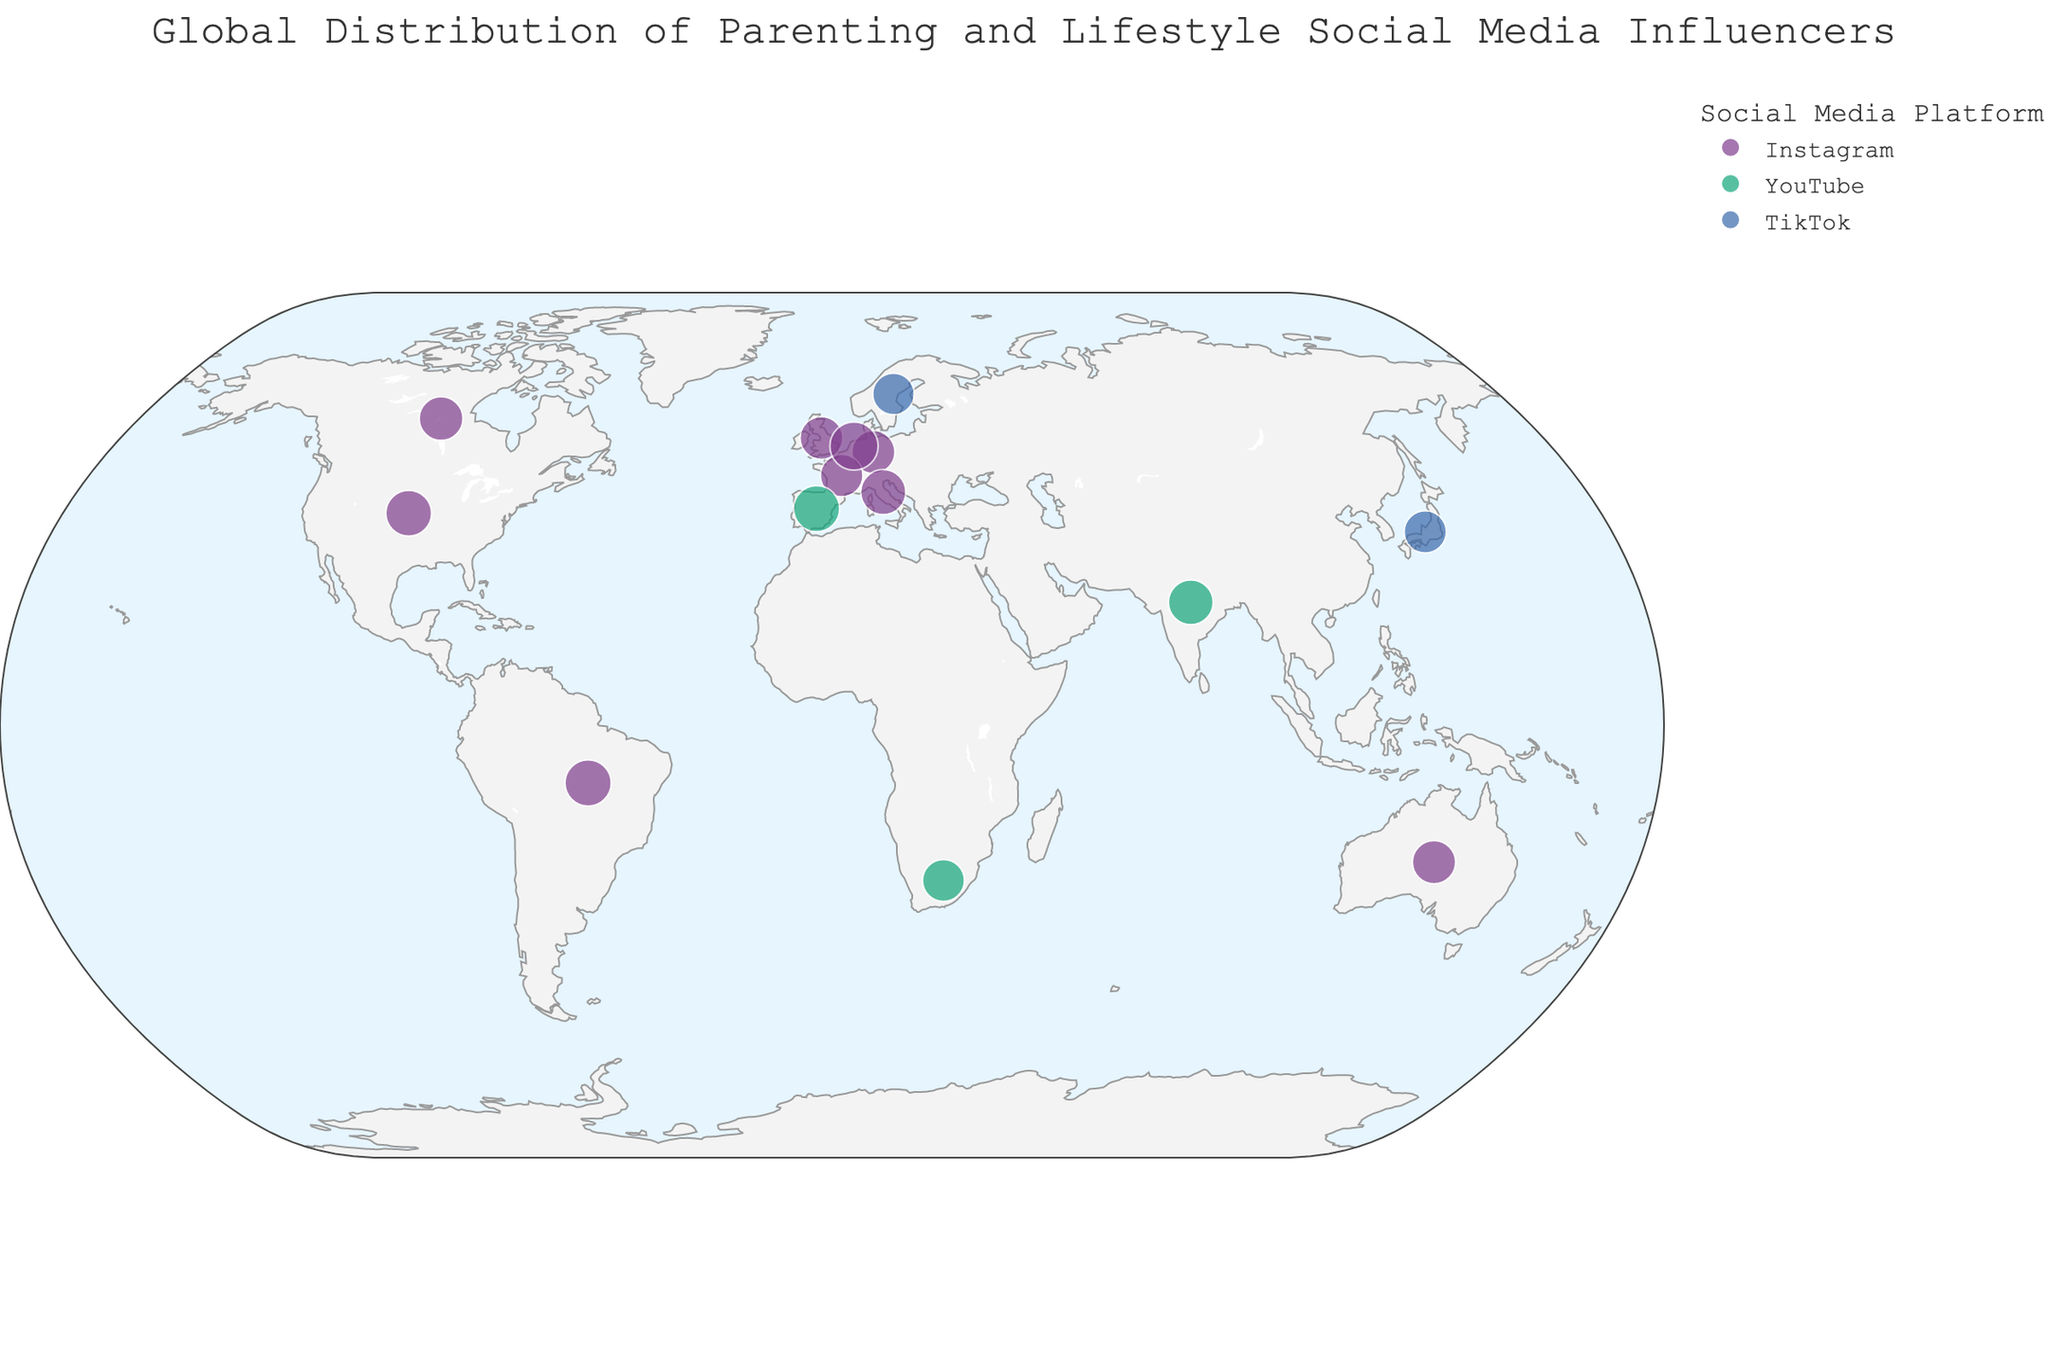What's the title of the figure? Look at the top of the plot where the title is centered.
Answer: "Global Distribution of Parenting and Lifestyle Social Media Influencers" Which social media platform has the most diversity in countries represented? Observe the variety of colors representing different platforms across the countries on the map.
Answer: Instagram Which influencer from Spain has a large following? Check the location marked in Spain and hover over it to see the influencer's details.
Answer: Verdeliss Which country has the influencer with the highest number of followers? Survey the scatter points and identify the largest one. Then, check the corresponding country.
Answer: Netherlands Which platform has influencers with the largest followings in general? Notice the size of the scatter points and identify the platform frequently associated with the largest points.
Answer: Instagram How many influencers are represented from the United States? Count the number of scatter points located in the United States.
Answer: 1 Who is the influencer focused on large family life content? Look at the hover data for content focus and identify the influencer related to Large Family Life.
Answer: Verdeliss What's the total number of followers for influencers from Australia and Germany combined? Find the follower counts for influencers in Australia and Germany and add them together: 320,000 (Australia) + 290,000 (Germany).
Answer: 610,000 Which influencer from Brazil focuses on healthy living and parenting? See the influencer's information in the Brazil location and check the content focus.
Answer: Bela Gil What's the primary content focus of influencers from Canada and Italy? Review the hover data for influencers from Canada and Italy and note the content focus mentioned.
Answer: Family Travel and Lifestyle (Canada), Family Comedy and Lifestyle (Italy) 